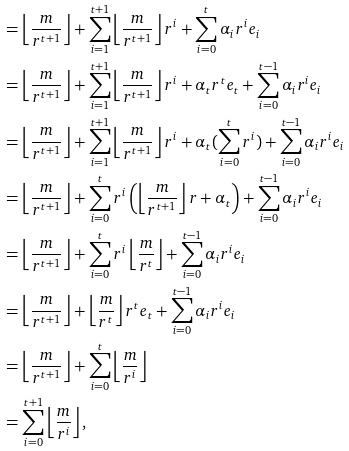<formula> <loc_0><loc_0><loc_500><loc_500>& = \left \lfloor \frac { m } { r ^ { t + 1 } } \right \rfloor + \sum _ { i = 1 } ^ { t + 1 } \left \lfloor \frac { m } { r ^ { t + 1 } } \right \rfloor r ^ { i } + \sum _ { i = 0 } ^ { t } \alpha _ { i } r ^ { i } e _ { i } \\ & = \left \lfloor \frac { m } { r ^ { t + 1 } } \right \rfloor + \sum _ { i = 1 } ^ { t + 1 } \left \lfloor \frac { m } { r ^ { t + 1 } } \right \rfloor r ^ { i } + \alpha _ { t } r ^ { t } e _ { t } + \sum _ { i = 0 } ^ { t - 1 } \alpha _ { i } r ^ { i } e _ { i } \\ & = \left \lfloor \frac { m } { r ^ { t + 1 } } \right \rfloor + \sum _ { i = 1 } ^ { t + 1 } \left \lfloor \frac { m } { r ^ { t + 1 } } \right \rfloor r ^ { i } + \alpha _ { t } ( \sum _ { i = 0 } ^ { t } r ^ { i } ) + \sum _ { i = 0 } ^ { t - 1 } \alpha _ { i } r ^ { i } e _ { i } \\ & = \left \lfloor \frac { m } { r ^ { t + 1 } } \right \rfloor + \sum _ { i = 0 } ^ { t } r ^ { i } \left ( \left \lfloor \frac { m } { r ^ { t + 1 } } \right \rfloor r + \alpha _ { t } \right ) + \sum _ { i = 0 } ^ { t - 1 } \alpha _ { i } r ^ { i } e _ { i } \\ & = \left \lfloor \frac { m } { r ^ { t + 1 } } \right \rfloor + \sum _ { i = 0 } ^ { t } r ^ { i } \left \lfloor \frac { m } { r ^ { t } } \right \rfloor + \sum _ { i = 0 } ^ { t - 1 } \alpha _ { i } r ^ { i } e _ { i } \\ & = \left \lfloor \frac { m } { r ^ { t + 1 } } \right \rfloor + \left \lfloor \frac { m } { r ^ { t } } \right \rfloor r ^ { t } e _ { t } + \sum _ { i = 0 } ^ { t - 1 } \alpha _ { i } r ^ { i } e _ { i } \\ & = \left \lfloor \frac { m } { r ^ { t + 1 } } \right \rfloor + \sum _ { i = 0 } ^ { t } \left \lfloor \frac { m } { r ^ { i } } \right \rfloor \\ & = \sum _ { i = 0 } ^ { t + 1 } \left \lfloor \frac { m } { r ^ { i } } \right \rfloor ,</formula> 